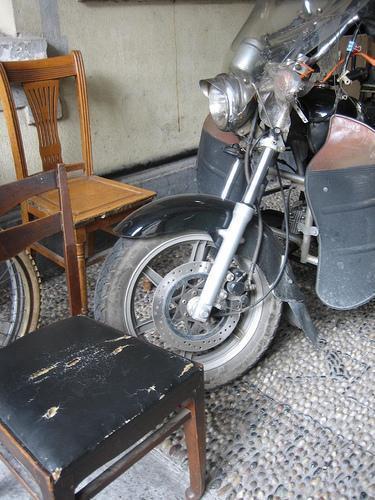How many chairs have a cushion?
Give a very brief answer. 1. How many tires do you see?
Give a very brief answer. 2. How many chairs can be seen?
Give a very brief answer. 2. How many bananas is there?
Give a very brief answer. 0. 